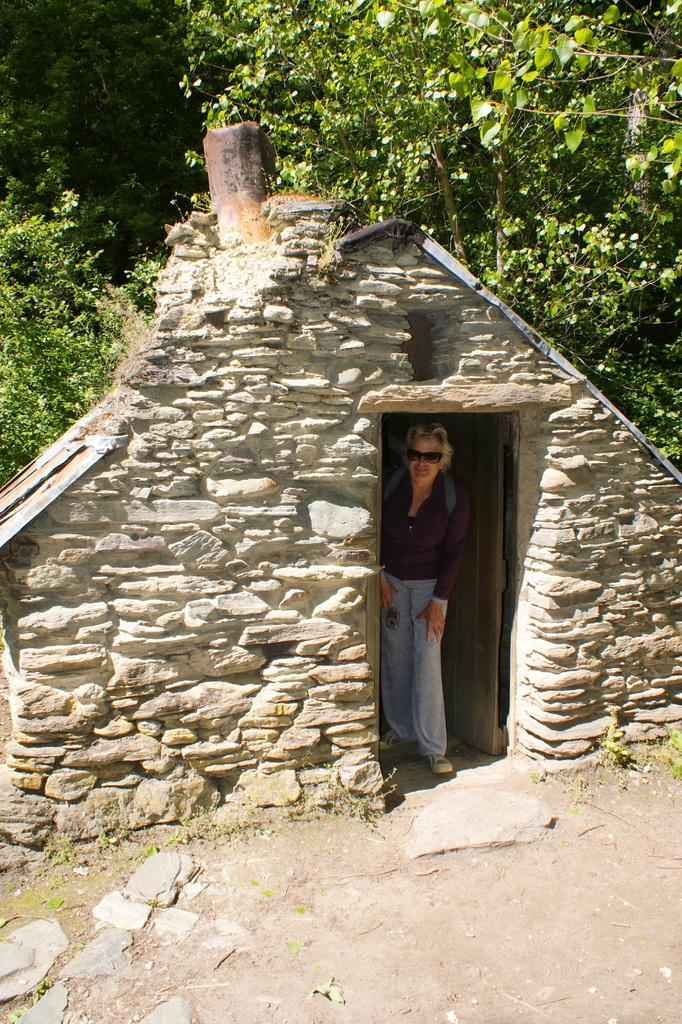What is the person in the image doing? The person is standing inside the house. What can be seen from the back side of the house? Trees are visible from the back side of the house. What type of potato is being cooked in the tent outside the house? There is no potato or tent present in the image; the image only shows a person standing inside the house and trees visible from the back side of the house. 